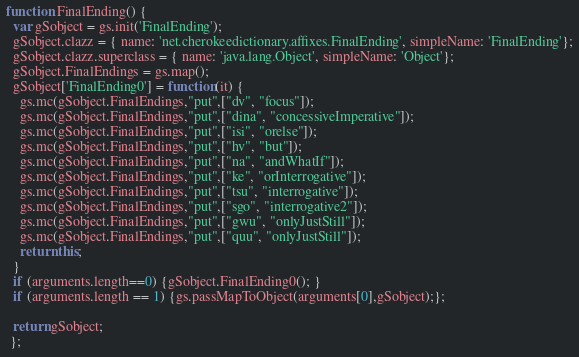<code> <loc_0><loc_0><loc_500><loc_500><_JavaScript_>function FinalEnding() {
  var gSobject = gs.init('FinalEnding');
  gSobject.clazz = { name: 'net.cherokeedictionary.affixes.FinalEnding', simpleName: 'FinalEnding'};
  gSobject.clazz.superclass = { name: 'java.lang.Object', simpleName: 'Object'};
  gSobject.FinalEndings = gs.map();
  gSobject['FinalEnding0'] = function(it) {
    gs.mc(gSobject.FinalEndings,"put",["dv", "focus"]);
    gs.mc(gSobject.FinalEndings,"put",["dina", "concessiveImperative"]);
    gs.mc(gSobject.FinalEndings,"put",["isi", "orelse"]);
    gs.mc(gSobject.FinalEndings,"put",["hv", "but"]);
    gs.mc(gSobject.FinalEndings,"put",["na", "andWhatIf"]);
    gs.mc(gSobject.FinalEndings,"put",["ke", "orInterrogative"]);
    gs.mc(gSobject.FinalEndings,"put",["tsu", "interrogative"]);
    gs.mc(gSobject.FinalEndings,"put",["sgo", "interrogative2"]);
    gs.mc(gSobject.FinalEndings,"put",["gwu", "onlyJustStill"]);
    gs.mc(gSobject.FinalEndings,"put",["quu", "onlyJustStill"]);
    return this;
  }
  if (arguments.length==0) {gSobject.FinalEnding0(); }
  if (arguments.length == 1) {gs.passMapToObject(arguments[0],gSobject);};
  
  return gSobject;
 };
</code> 